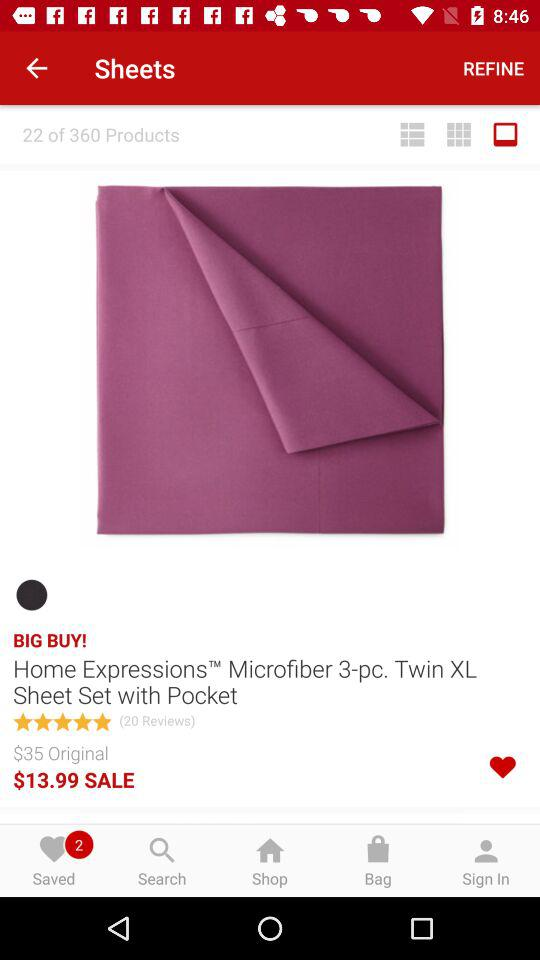What is the name of the application?
When the provided information is insufficient, respond with <no answer>. <no answer> 